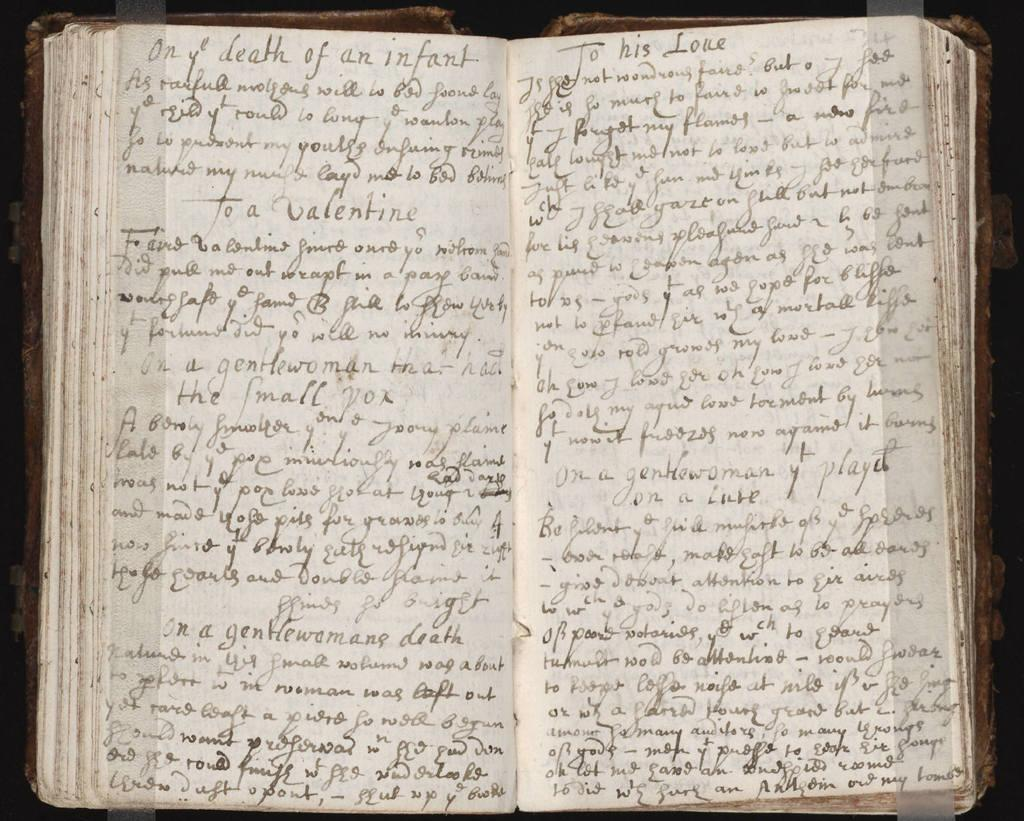<image>
Describe the image concisely. An old book lays open displaying titles such as "On the death of an infant" and "To his Love." 